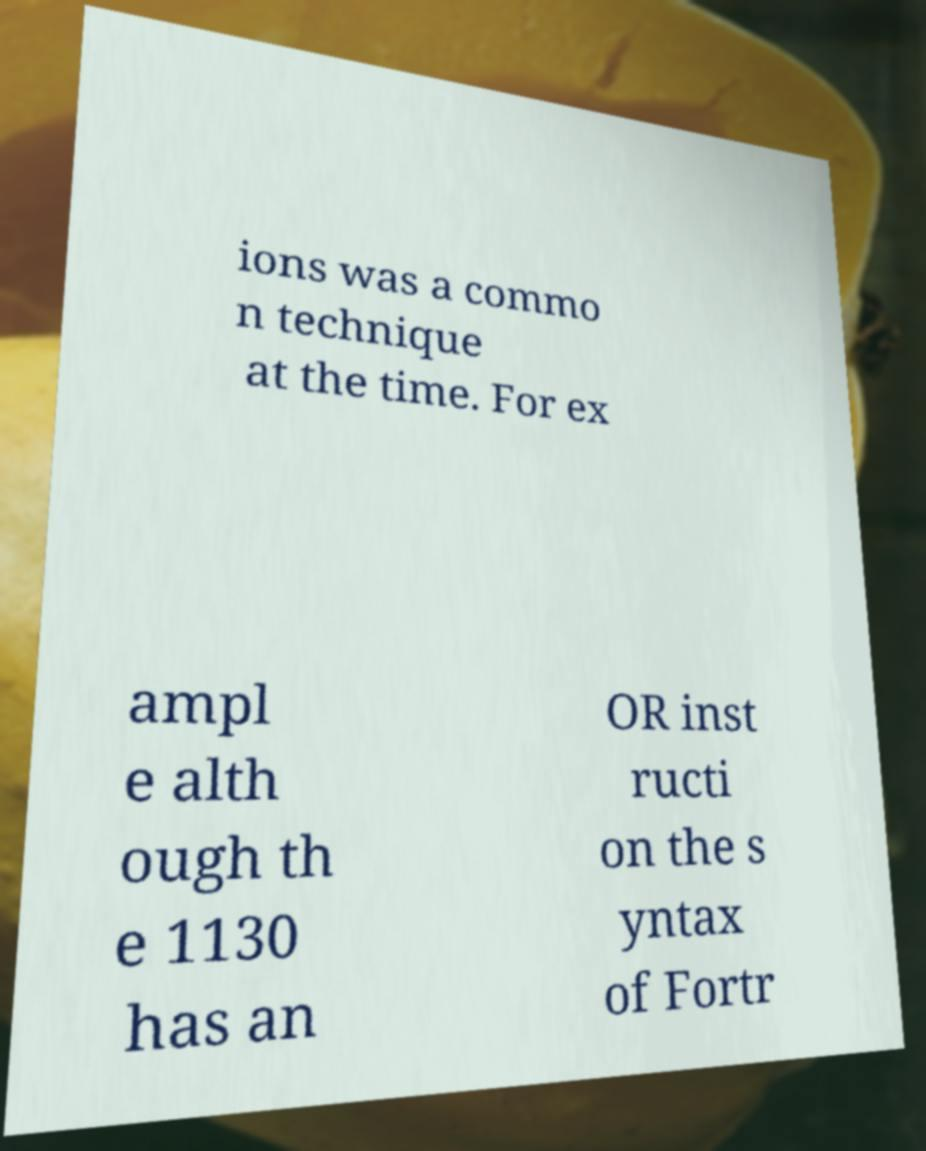Please identify and transcribe the text found in this image. ions was a commo n technique at the time. For ex ampl e alth ough th e 1130 has an OR inst ructi on the s yntax of Fortr 